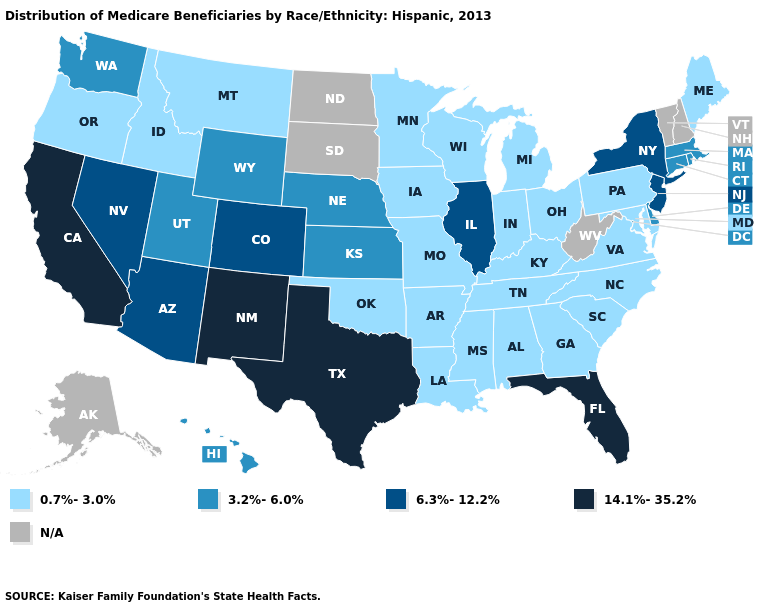Does the first symbol in the legend represent the smallest category?
Concise answer only. Yes. Does the map have missing data?
Answer briefly. Yes. Name the states that have a value in the range 3.2%-6.0%?
Short answer required. Connecticut, Delaware, Hawaii, Kansas, Massachusetts, Nebraska, Rhode Island, Utah, Washington, Wyoming. Name the states that have a value in the range 14.1%-35.2%?
Concise answer only. California, Florida, New Mexico, Texas. What is the value of North Dakota?
Concise answer only. N/A. Which states have the highest value in the USA?
Quick response, please. California, Florida, New Mexico, Texas. Among the states that border Texas , does New Mexico have the lowest value?
Keep it brief. No. What is the value of Rhode Island?
Keep it brief. 3.2%-6.0%. What is the lowest value in states that border Vermont?
Quick response, please. 3.2%-6.0%. Name the states that have a value in the range 3.2%-6.0%?
Short answer required. Connecticut, Delaware, Hawaii, Kansas, Massachusetts, Nebraska, Rhode Island, Utah, Washington, Wyoming. Does Kentucky have the lowest value in the USA?
Short answer required. Yes. What is the value of Arkansas?
Quick response, please. 0.7%-3.0%. Does Utah have the lowest value in the USA?
Give a very brief answer. No. 